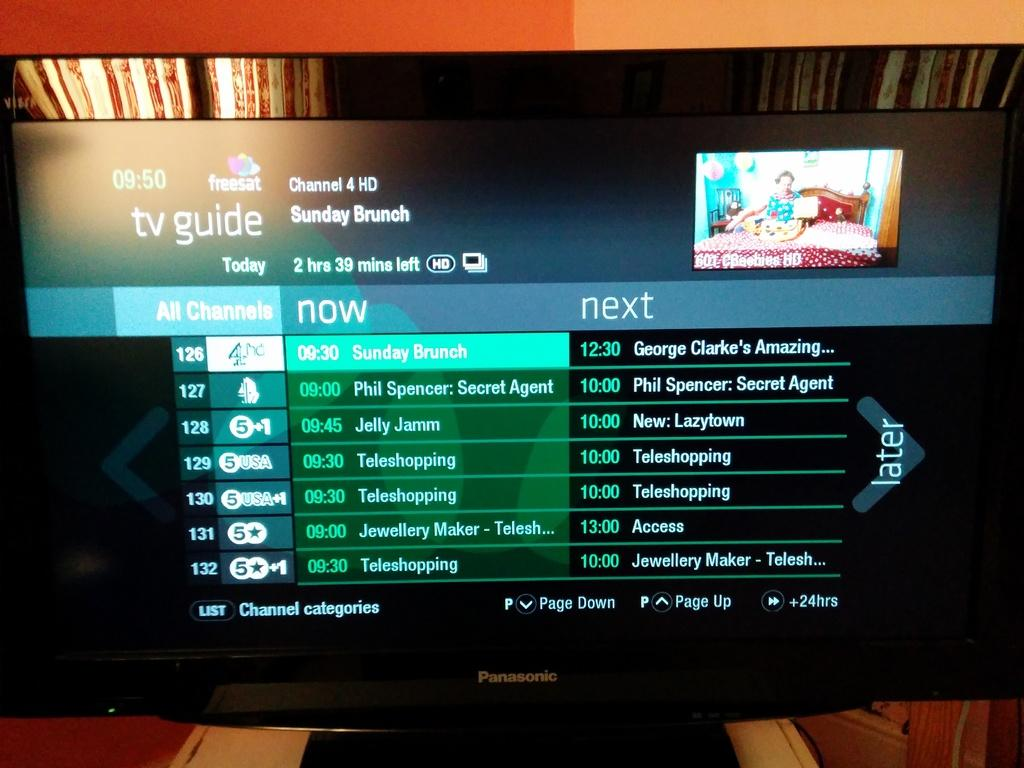Provide a one-sentence caption for the provided image. A Panasonic tv that has the TV Guide displayed on the screen.. 